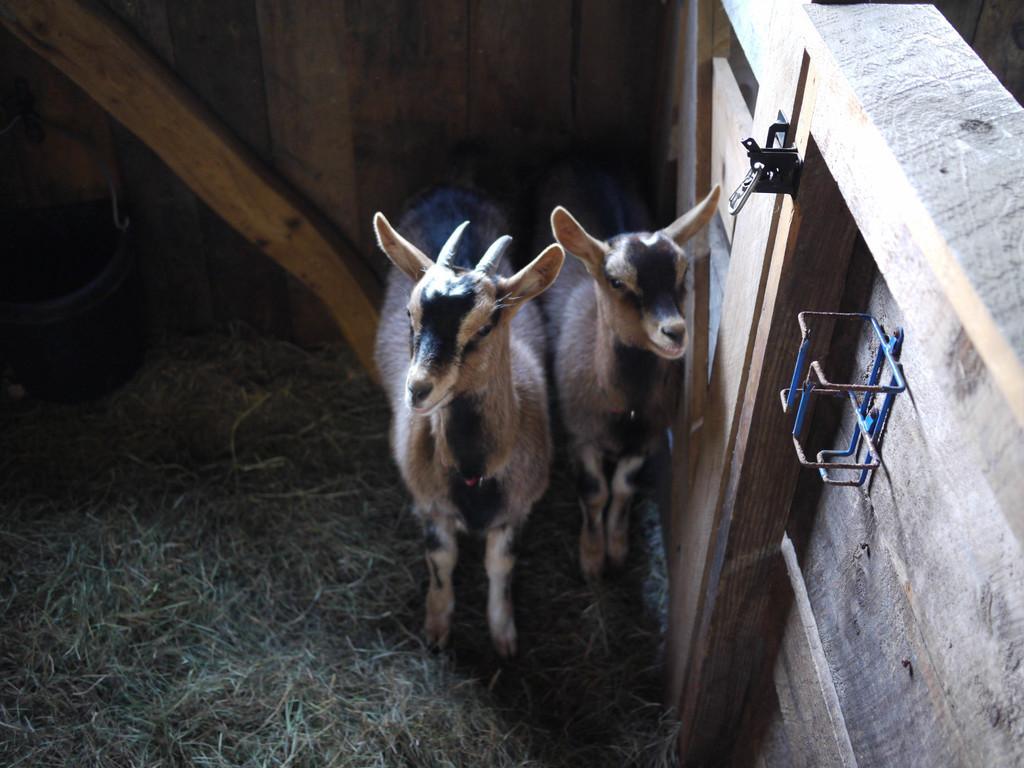In one or two sentences, can you explain what this image depicts? These are the two goats, this is the wooden wall. This is the grass. 